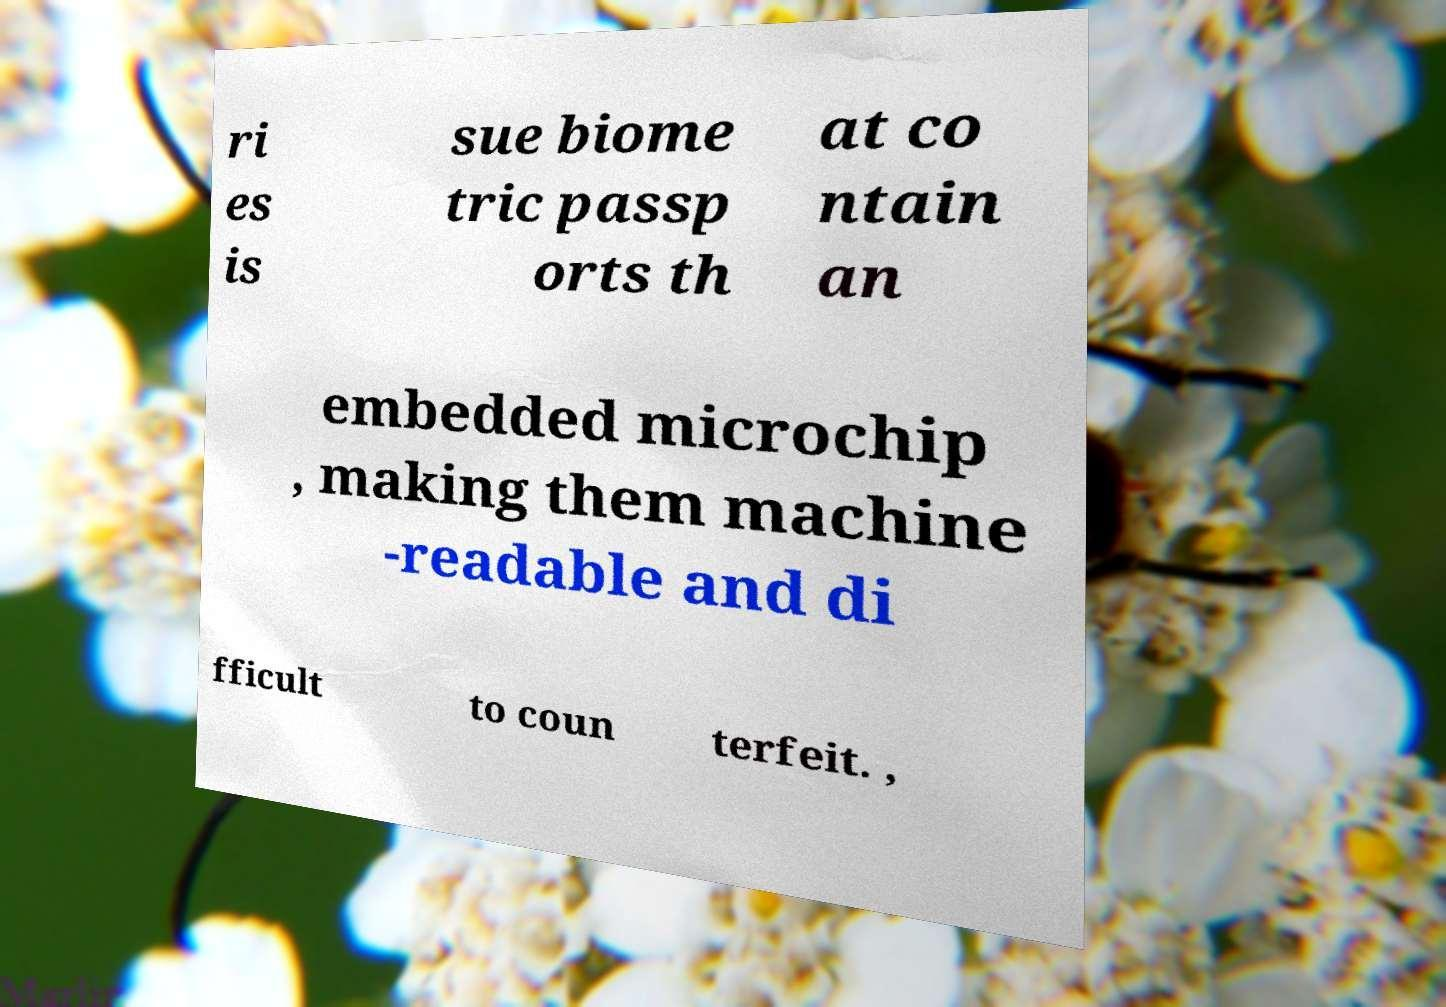There's text embedded in this image that I need extracted. Can you transcribe it verbatim? ri es is sue biome tric passp orts th at co ntain an embedded microchip , making them machine -readable and di fficult to coun terfeit. , 